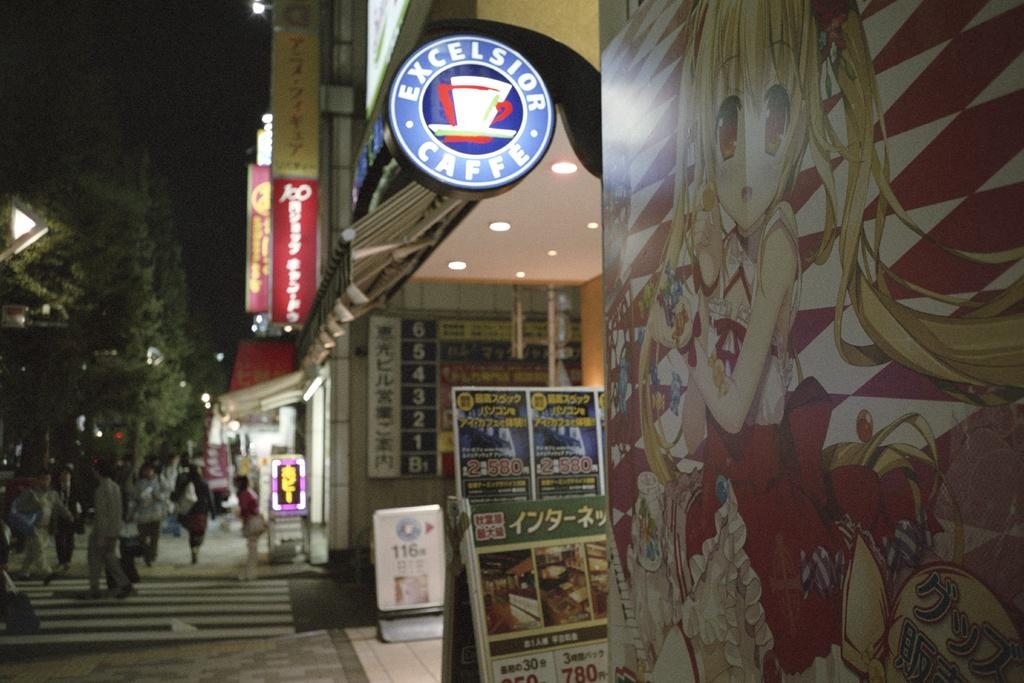Provide a one-sentence caption for the provided image. A round coffee shop sign is lit to reveal the name Excelsior Caffe. 